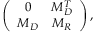<formula> <loc_0><loc_0><loc_500><loc_500>\left ( \begin{array} { c c } { 0 } & { { M _ { D } ^ { T } } } \\ { { M _ { D } } } & { { M _ { R } } } \end{array} \right ) ,</formula> 